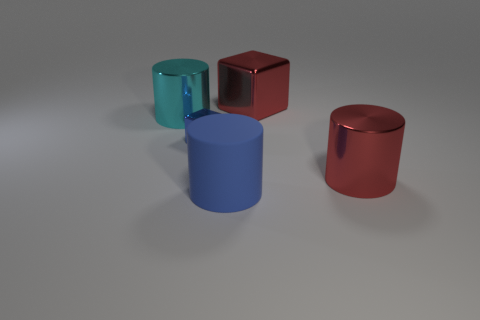Add 4 gray metallic balls. How many objects exist? 9 Subtract all cyan shiny cylinders. How many cylinders are left? 2 Subtract all red cylinders. How many cylinders are left? 2 Subtract 2 cylinders. How many cylinders are left? 1 Subtract all large blue cylinders. Subtract all small things. How many objects are left? 3 Add 5 big rubber things. How many big rubber things are left? 6 Add 1 cyan metallic things. How many cyan metallic things exist? 2 Subtract 0 brown cylinders. How many objects are left? 5 Subtract all cubes. How many objects are left? 3 Subtract all yellow cylinders. Subtract all green balls. How many cylinders are left? 3 